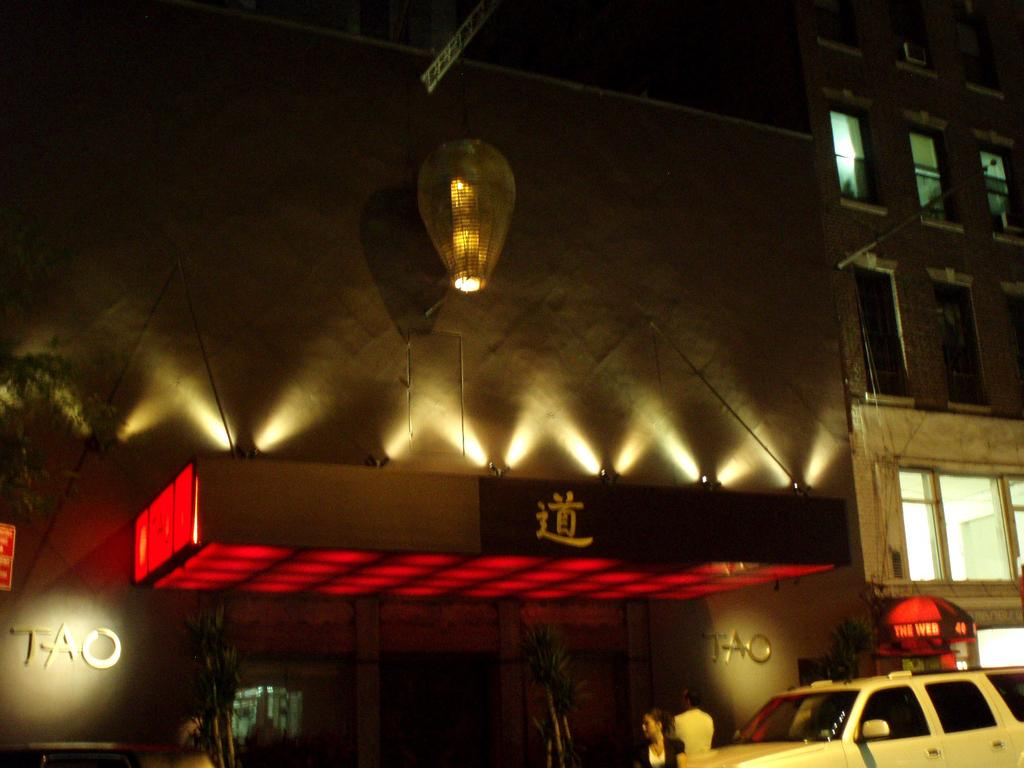<image>
Relay a brief, clear account of the picture shown. a Chinese restaurant called Tao is next to a place called The Web 